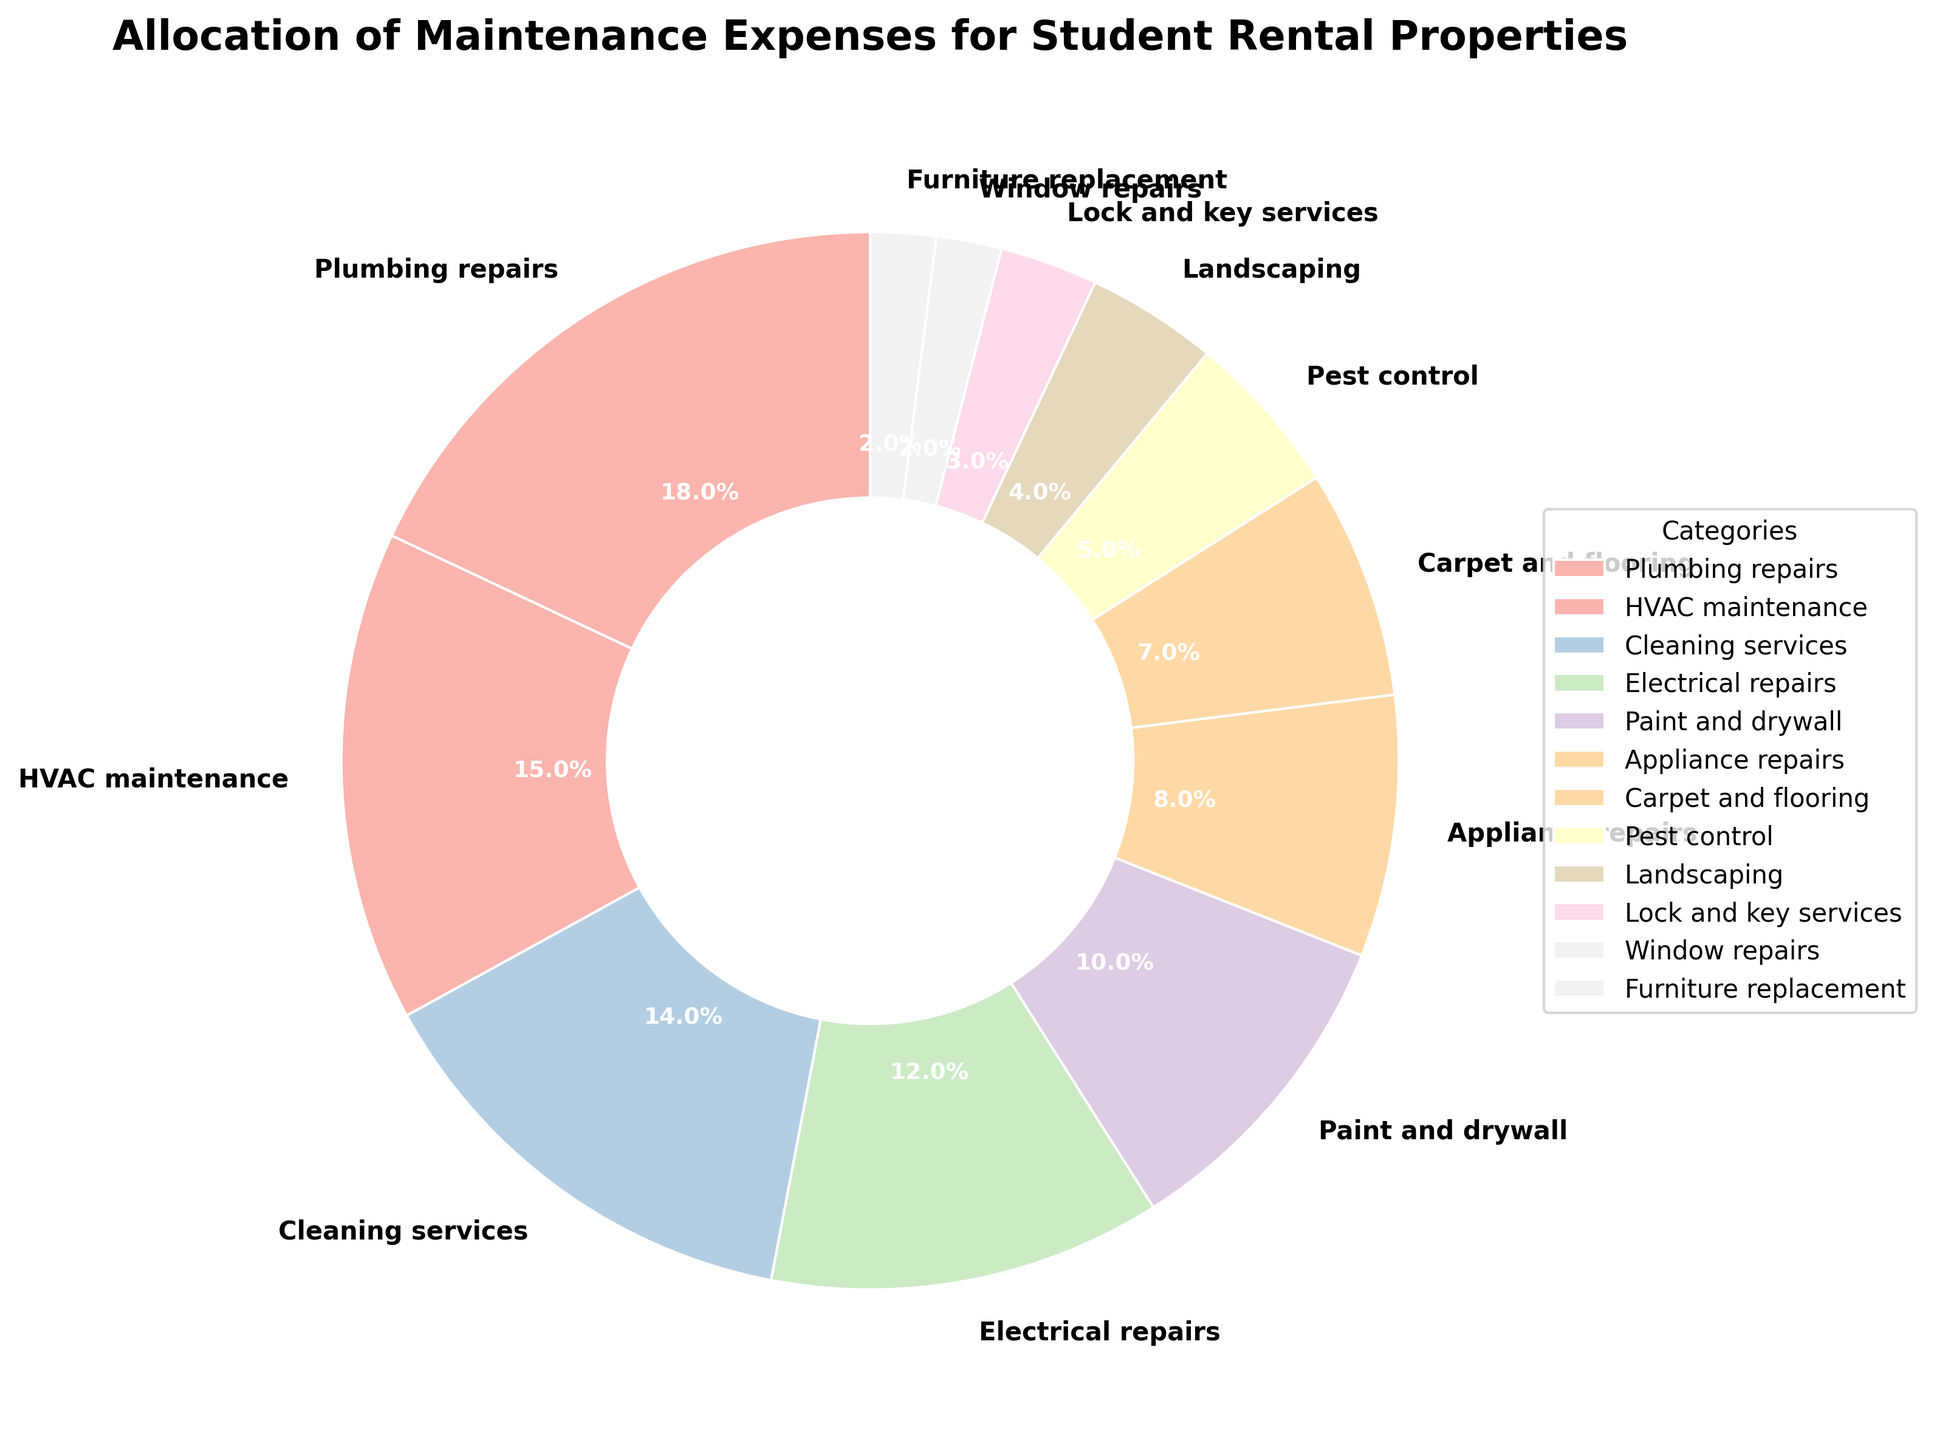What's the percentage of expenses allocated to Plumbing repairs? The pie chart assigns a specific percentage to each category. Locate "Plumbing repairs" and read its value.
Answer: 18% Which category has the smallest percentage allocation? Identify the category with the smallest visual wedge in the pie chart and check its associated percentage.
Answer: Window repairs and Furniture replacement How does the percentage for HVAC maintenance compare to Cleaning services? Look at the respective percentages: HVAC maintenance is 15% and Cleaning services is 14%. Compare them directly.
Answer: HVAC maintenance is 1% higher What is the combined percentage of Plumbing repairs and HVAC maintenance? Sum the percentages of Plumbing repairs (18%) and HVAC maintenance (15%).
Answer: 33% What is the difference in percentage between Electrical repairs and Pest control? Subtract the percentage for Pest control (5%) from Electrical repairs (12%).
Answer: 7% Which categories have a percentage less than 10%? Identify all categories with a percentage value under 10%.
Answer: Appliance repairs, Carpet and flooring, Pest control, Landscaping, Lock and key services, Window repairs, Furniture replacement What is the sum of the percentages for categories related to the structure of the property (Plumbing repairs, HVAC maintenance, Electrical repairs, Paint and drywall, Window repairs)? Add the percentages for these categories: Plumbing repairs (18%), HVAC maintenance (15%), Electrical repairs (12%), Paint and drywall (10%), Window repairs (2%).
Answer: 57% Which category is visually represented with a larger wedge, Appliance repairs or Carpet and flooring? Compare the size of the wedges for Appliance repairs (8%) and Carpet and flooring (7%).
Answer: Appliance repairs What is the visual color associated with the largest expense allocation? Locate the largest wedge (Plumbing repairs) and observe its color in the pie chart.
Answer: Light color (specific hue depends on shading) 